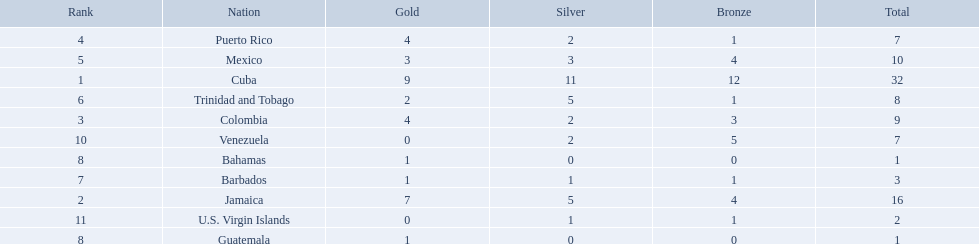What nation has won at least 4 gold medals? Cuba, Jamaica, Colombia, Puerto Rico. Of these countries who has won the least amount of bronze medals? Puerto Rico. 